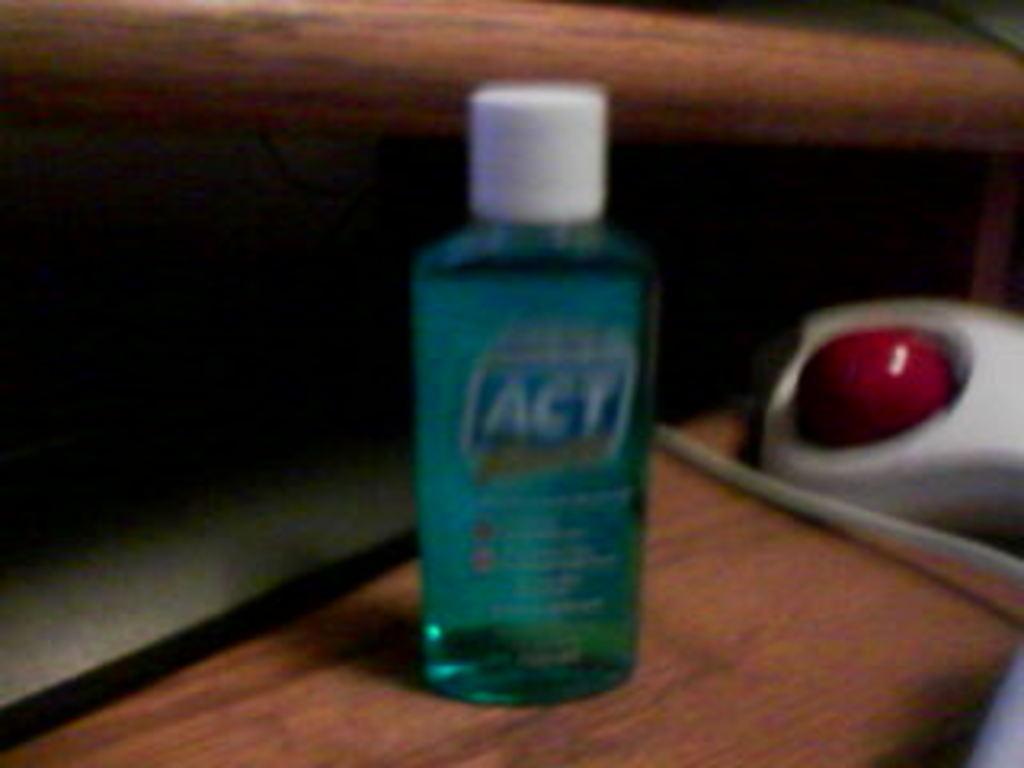How would you summarize this image in a sentence or two? In the picture we can see a bottle of liquid which is blue in color placed on the wooden table and just beside to it we can see a red color button on the white substance. 